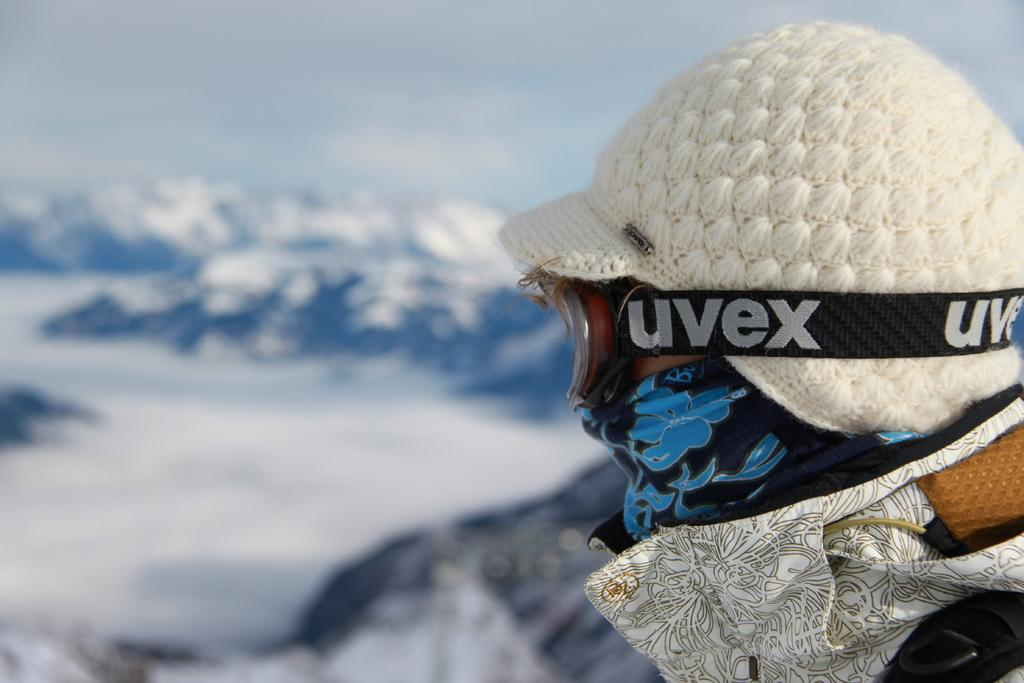What is the person in the image wearing on their head? The person is wearing a cap in the image. What type of eyewear is the person wearing? The person is wearing spectacles in the image. What type of landscape can be seen in the image? Hills are visible in the image. What is the condition of the sky in the image? The sky is cloudy in the image. Where is the coat hanging on a hook in the image? There is no coat or hook present in the image. 